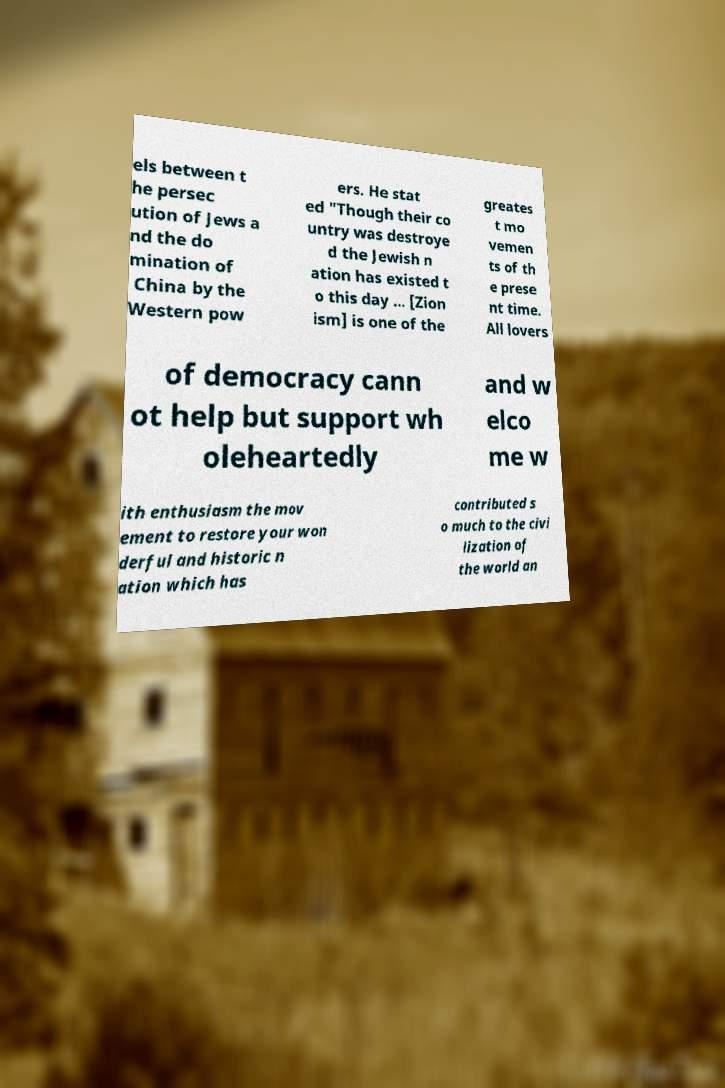For documentation purposes, I need the text within this image transcribed. Could you provide that? els between t he persec ution of Jews a nd the do mination of China by the Western pow ers. He stat ed "Though their co untry was destroye d the Jewish n ation has existed t o this day ... [Zion ism] is one of the greates t mo vemen ts of th e prese nt time. All lovers of democracy cann ot help but support wh oleheartedly and w elco me w ith enthusiasm the mov ement to restore your won derful and historic n ation which has contributed s o much to the civi lization of the world an 